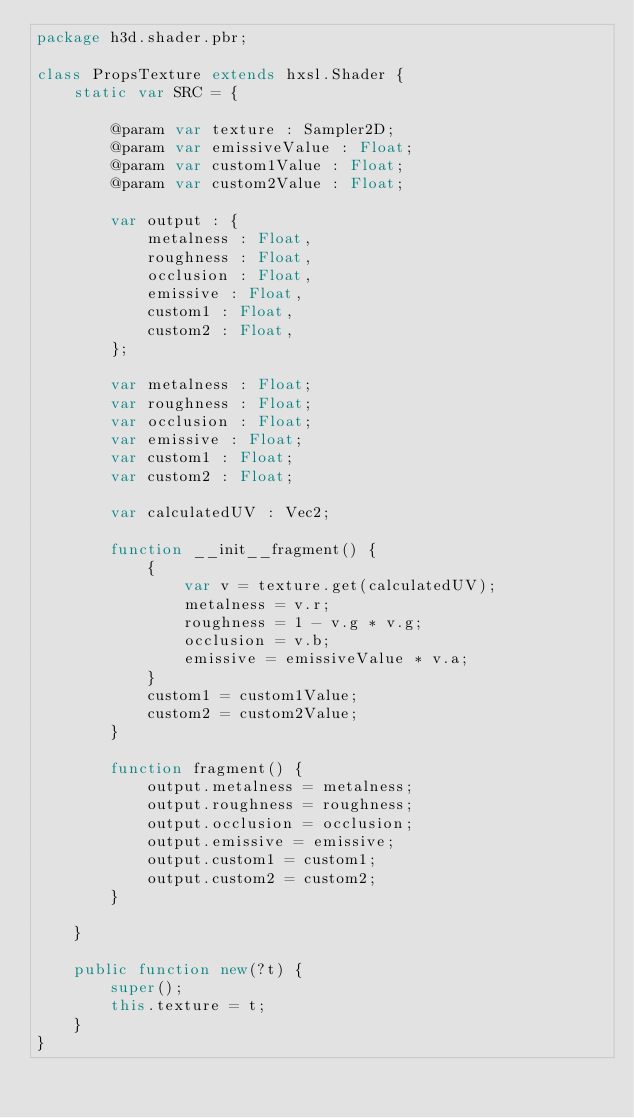<code> <loc_0><loc_0><loc_500><loc_500><_Haxe_>package h3d.shader.pbr;

class PropsTexture extends hxsl.Shader {
	static var SRC = {

		@param var texture : Sampler2D;
		@param var emissiveValue : Float;
		@param var custom1Value : Float;
		@param var custom2Value : Float;

		var output : {
			metalness : Float,
			roughness : Float,
			occlusion : Float,
			emissive : Float,
			custom1 : Float,
			custom2 : Float,
		};

		var metalness : Float;
		var roughness : Float;
		var occlusion : Float;
		var emissive : Float;
		var custom1 : Float;
		var custom2 : Float;

		var calculatedUV : Vec2;

		function __init__fragment() {
			{
				var v = texture.get(calculatedUV);
				metalness = v.r;
				roughness = 1 - v.g * v.g;
				occlusion = v.b;
				emissive = emissiveValue * v.a;
			}
			custom1 = custom1Value;
			custom2 = custom2Value;
		}

		function fragment() {
			output.metalness = metalness;
			output.roughness = roughness;
			output.occlusion = occlusion;
			output.emissive = emissive;
			output.custom1 = custom1;
			output.custom2 = custom2;
		}

	}

	public function new(?t) {
		super();
		this.texture = t;
	}
}
</code> 